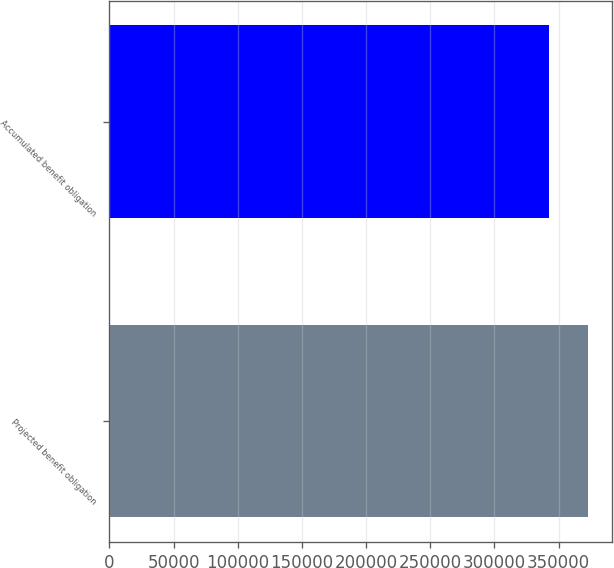Convert chart. <chart><loc_0><loc_0><loc_500><loc_500><bar_chart><fcel>Projected benefit obligation<fcel>Accumulated benefit obligation<nl><fcel>372931<fcel>342158<nl></chart> 